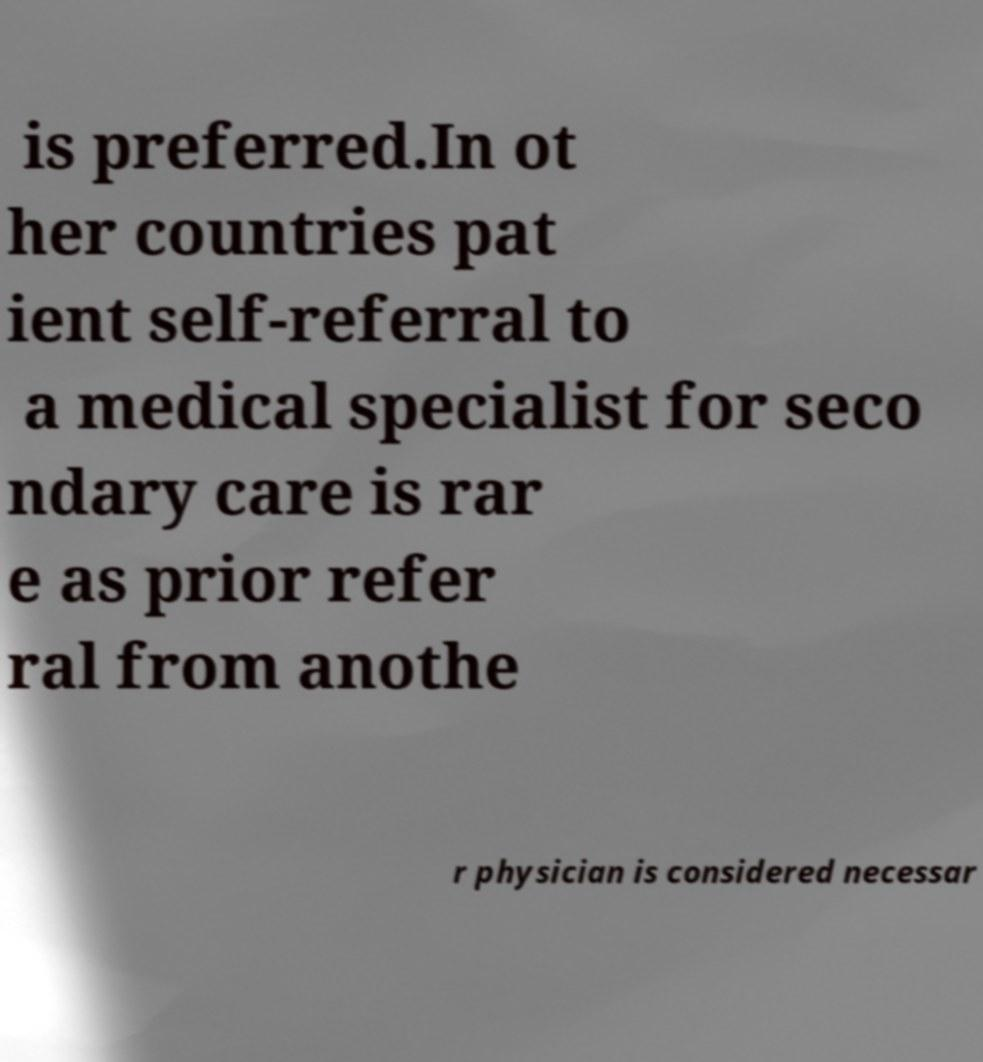Can you read and provide the text displayed in the image?This photo seems to have some interesting text. Can you extract and type it out for me? is preferred.In ot her countries pat ient self-referral to a medical specialist for seco ndary care is rar e as prior refer ral from anothe r physician is considered necessar 